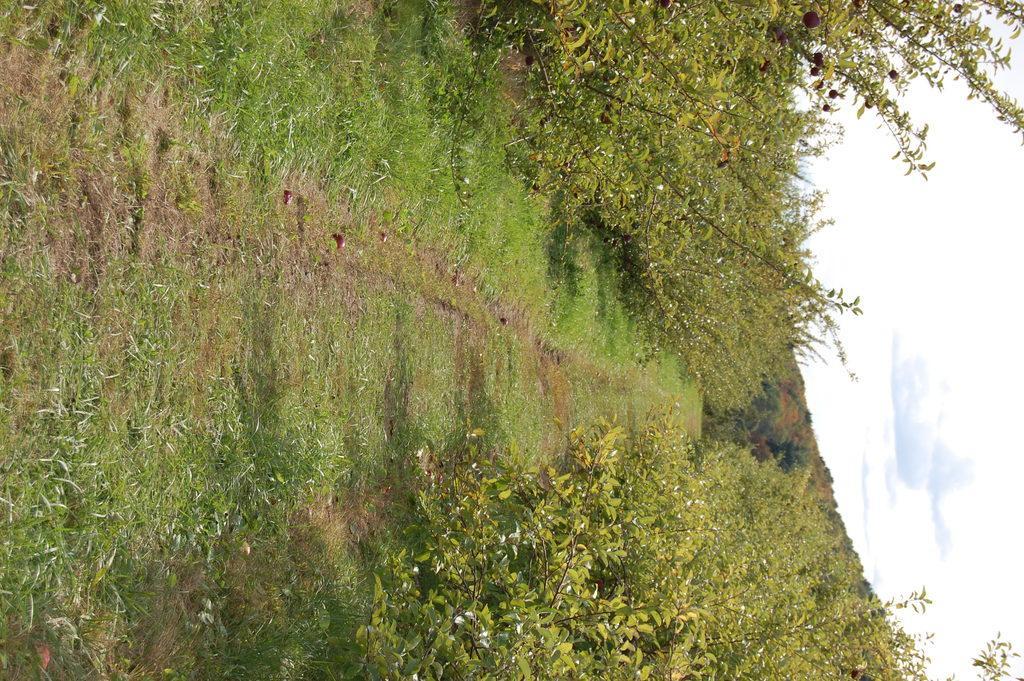Can you describe this image briefly? In this image we can see grass, plants, and trees. On the right side of the image we can see sky with clouds. 